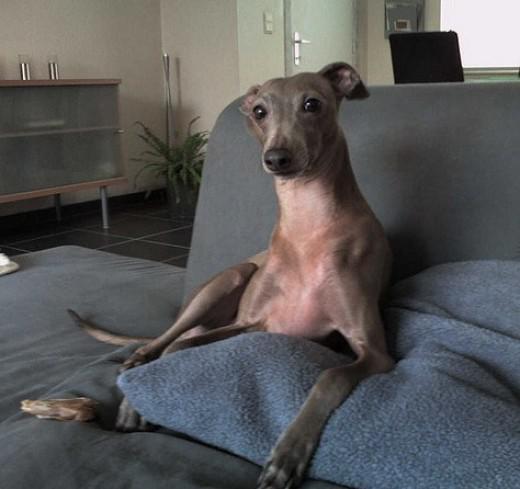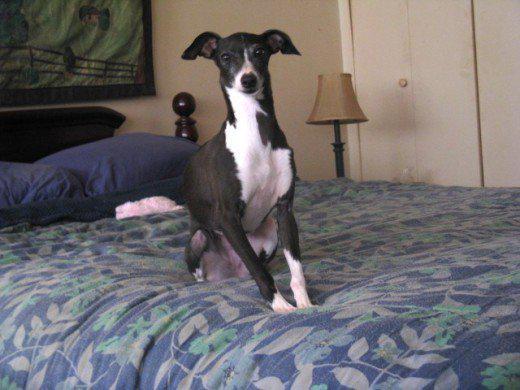The first image is the image on the left, the second image is the image on the right. Assess this claim about the two images: "One image shows a dog sitting upright, and the other shows at least one dog standing on all fours.". Correct or not? Answer yes or no. No. The first image is the image on the left, the second image is the image on the right. Considering the images on both sides, is "At least one of the dog is wearing a collar." valid? Answer yes or no. No. 